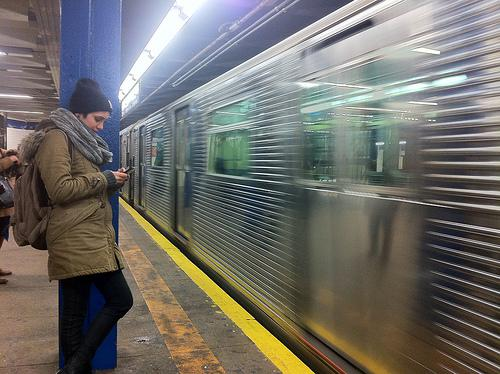Question: why is the girl waiting?
Choices:
A. Subway train hasn't stopped.
B. Her ride hasn't shown up.
C. She needs a taxi.
D. Her mom is on her way.
Answer with the letter. Answer: A Question: what color hat is the girl wearing?
Choices:
A. Black.
B. White.
C. Purple.
D. Green.
Answer with the letter. Answer: A Question: what color is the subway train?
Choices:
A. Gold.
B. Silver.
C. Black.
D. Brown.
Answer with the letter. Answer: B Question: where was this picture taken?
Choices:
A. A railway station.
B. A subway station.
C. The train station.
D. The bus station.
Answer with the letter. Answer: B 